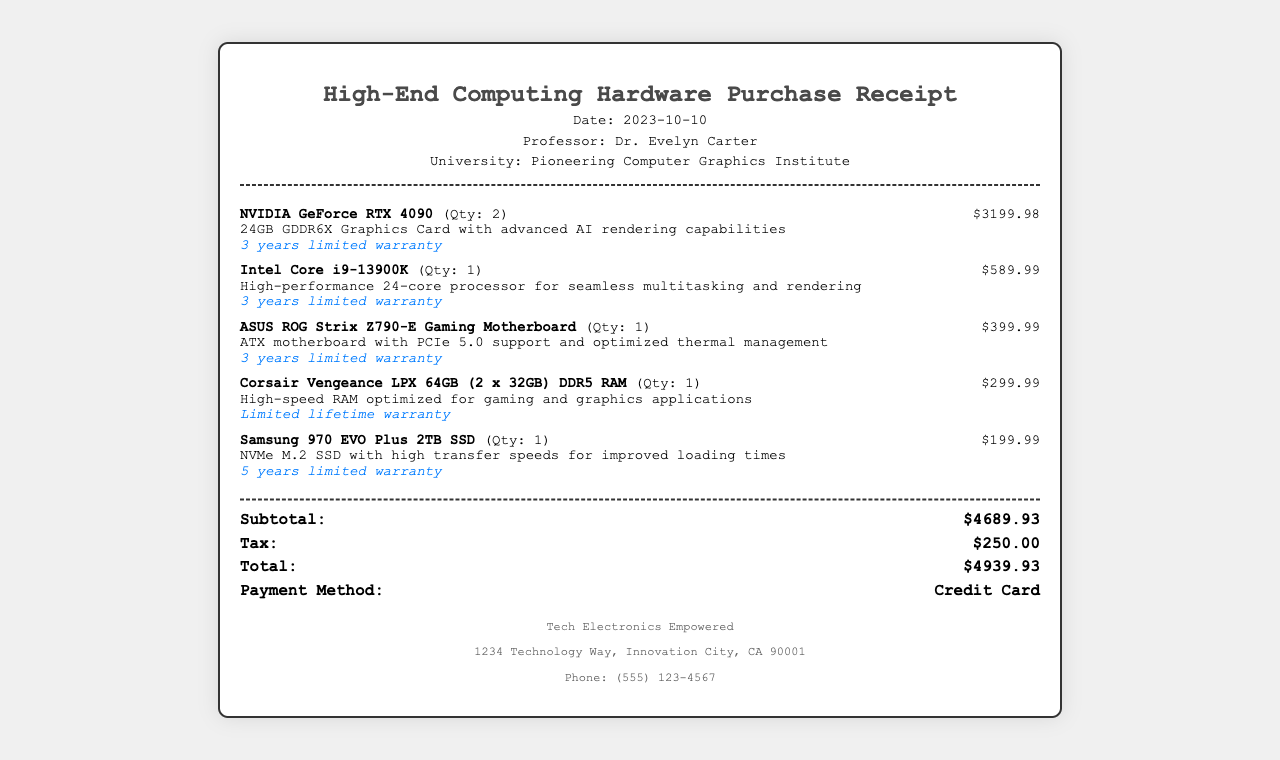What is the date of the purchase? The date of the purchase is explicitly mentioned in the header section of the receipt.
Answer: 2023-10-10 Who is the professor listed on the receipt? The professor's name is provided in the header, indicating the buyer of the hardware.
Answer: Dr. Evelyn Carter What is the total amount spent? The total amount is calculated and listed at the bottom of the receipt, including subtotal and tax.
Answer: $4939.93 How many NVIDIA GeForce RTX 4090 graphics cards were purchased? The quantity of the graphics cards is detailed in the item section of the receipt.
Answer: 2 What is the warranty period for the Intel Core i9-13900K processor? The warranty details for each item are listed with their descriptions under the items purchased.
Answer: 3 years limited warranty What is the price of the Samsung 970 EVO Plus 2TB SSD? The price of each item is clearly specified next to the item details in the receipt.
Answer: $199.99 What payment method was used for the purchase? Payment method information is provided in the totals section of the receipt.
Answer: Credit Card What type of RAM was bought? The type of RAM is described in the item details section of the receipt.
Answer: Corsair Vengeance LPX 64GB (2 x 32GB) DDR5 RAM What is the subtotal amount before tax? The subtotal figure is presented clearly in the totals section of the receipt, before any tax is added.
Answer: $4689.93 